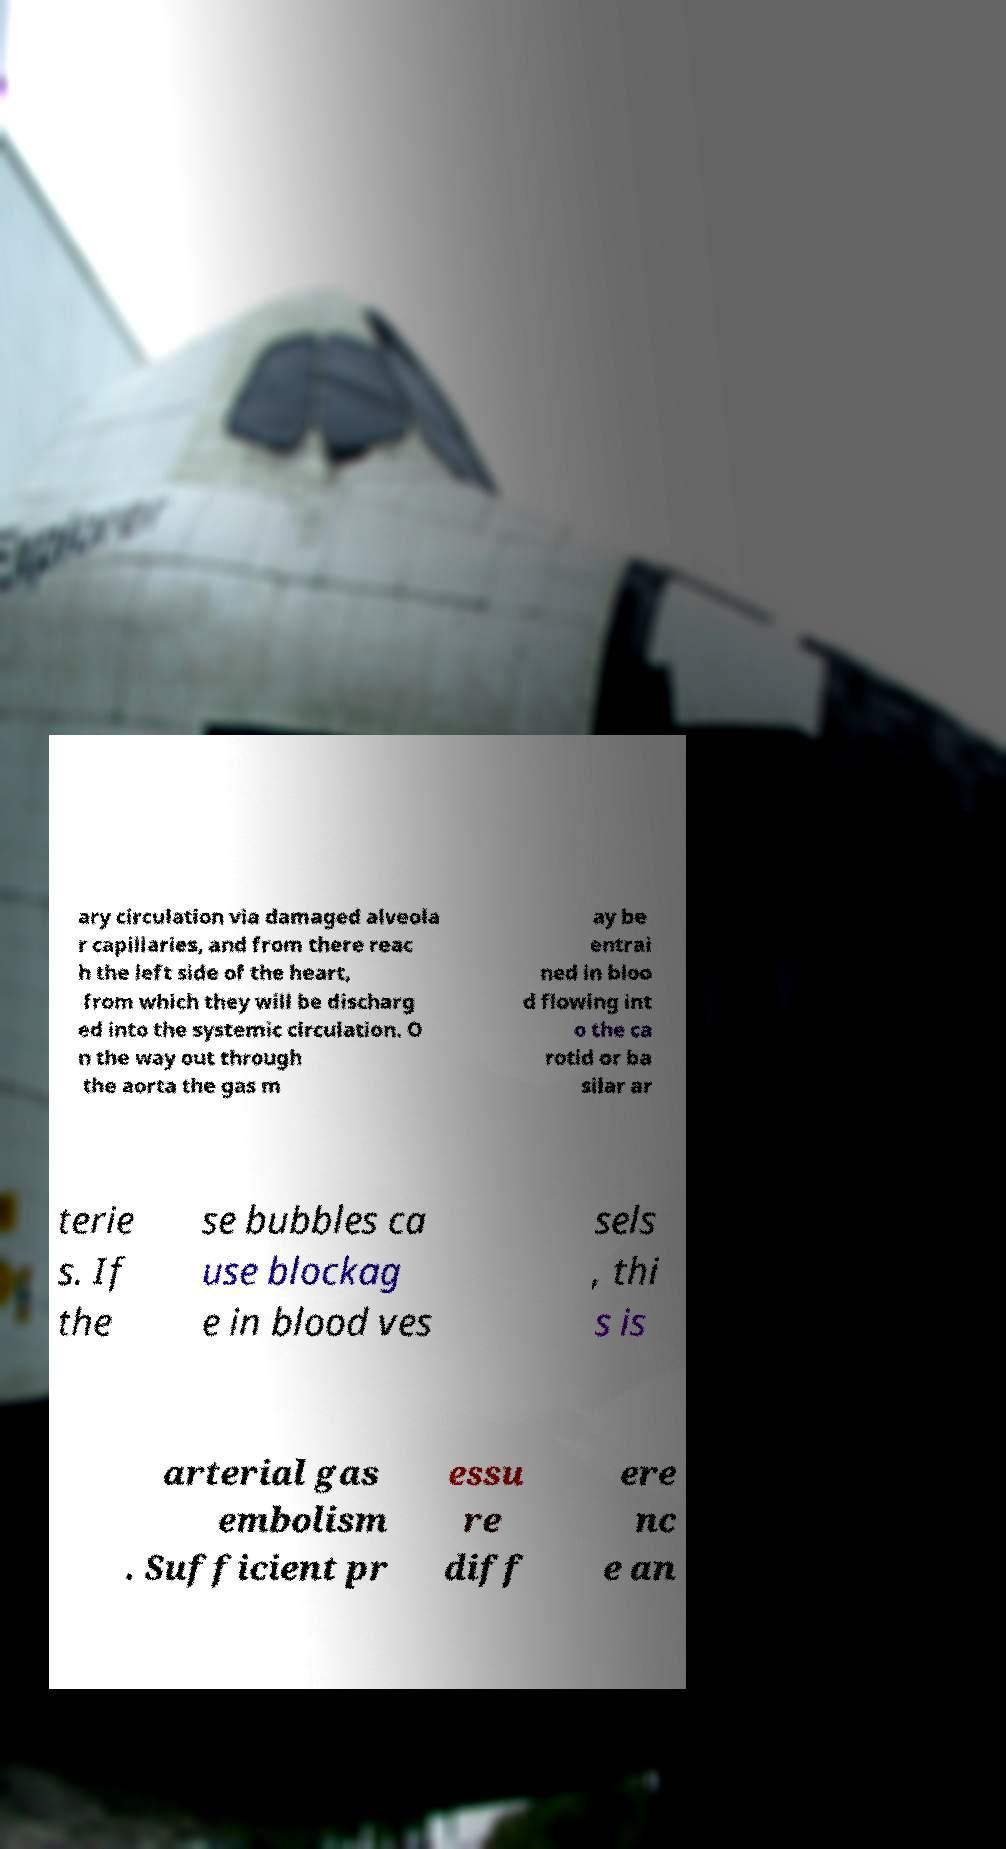Please read and relay the text visible in this image. What does it say? ary circulation via damaged alveola r capillaries, and from there reac h the left side of the heart, from which they will be discharg ed into the systemic circulation. O n the way out through the aorta the gas m ay be entrai ned in bloo d flowing int o the ca rotid or ba silar ar terie s. If the se bubbles ca use blockag e in blood ves sels , thi s is arterial gas embolism . Sufficient pr essu re diff ere nc e an 